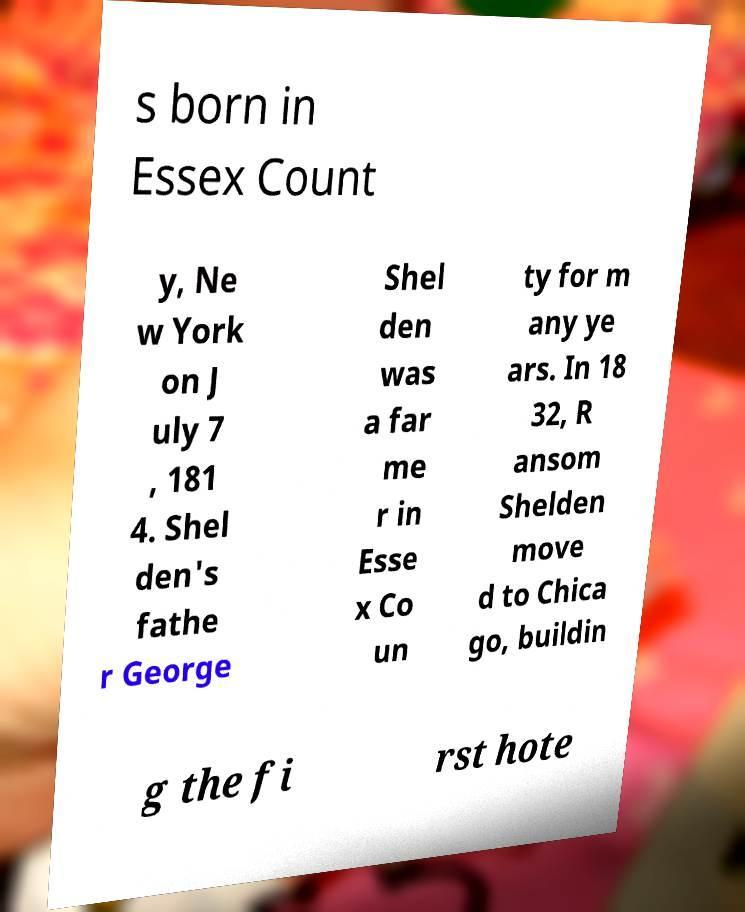Could you extract and type out the text from this image? s born in Essex Count y, Ne w York on J uly 7 , 181 4. Shel den's fathe r George Shel den was a far me r in Esse x Co un ty for m any ye ars. In 18 32, R ansom Shelden move d to Chica go, buildin g the fi rst hote 